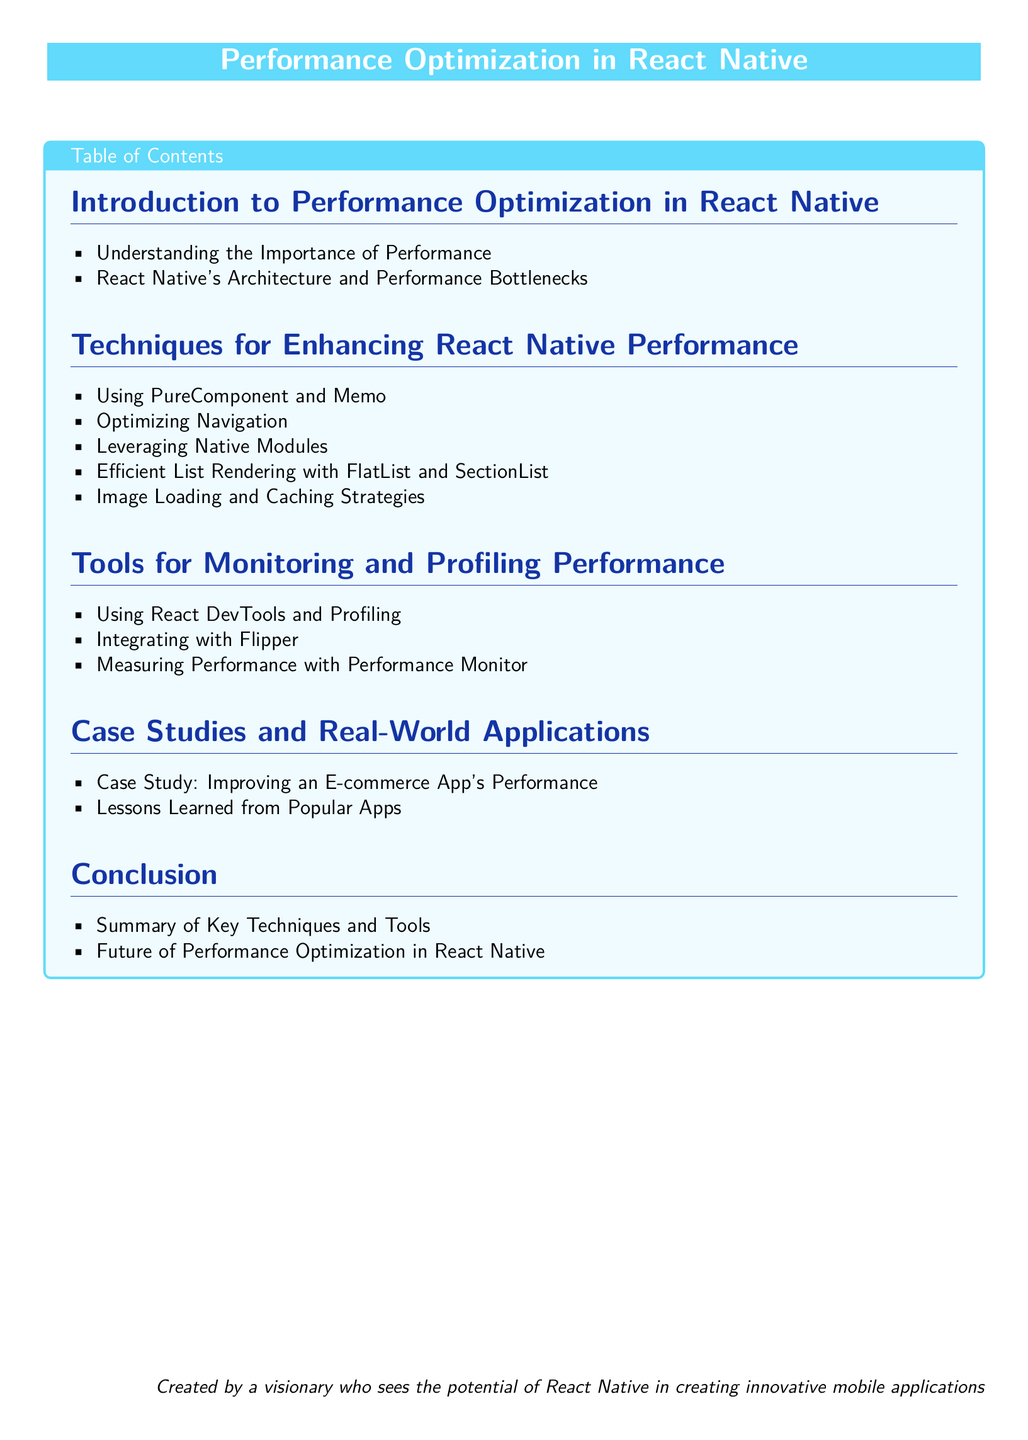What is the title of the document? The title of the document is displayed prominently at the top of the rendered content.
Answer: Performance Optimization in React Native How many main sections are there in the Table of Contents? The document has multiple sections, which can be counted in the Table of Contents.
Answer: Five What is the focus of the first section? The first section outlines basic information regarding performance in React Native, as noted in the Table of Contents.
Answer: Introduction to Performance Optimization in React Native Which technique is mentioned for enhancing list rendering? The document lists specific techniques in the second section, mentioning a particular method for list rendering.
Answer: FlatList and SectionList What tool is suggested for integrating with React Native performance monitoring? The document identifies specific tools in the third section related to performance, one of which is explicitly mentioned for integration.
Answer: Flipper What type of application is used in a case study for performance improvement? The document describes a real-world application type in the fourth section that underwent performance enhancement.
Answer: E-commerce App What is the last item listed in the conclusion section? The conclusion summarizes important insights, the last item specifically addresses future considerations in performance.
Answer: Future of Performance Optimization in React Native 